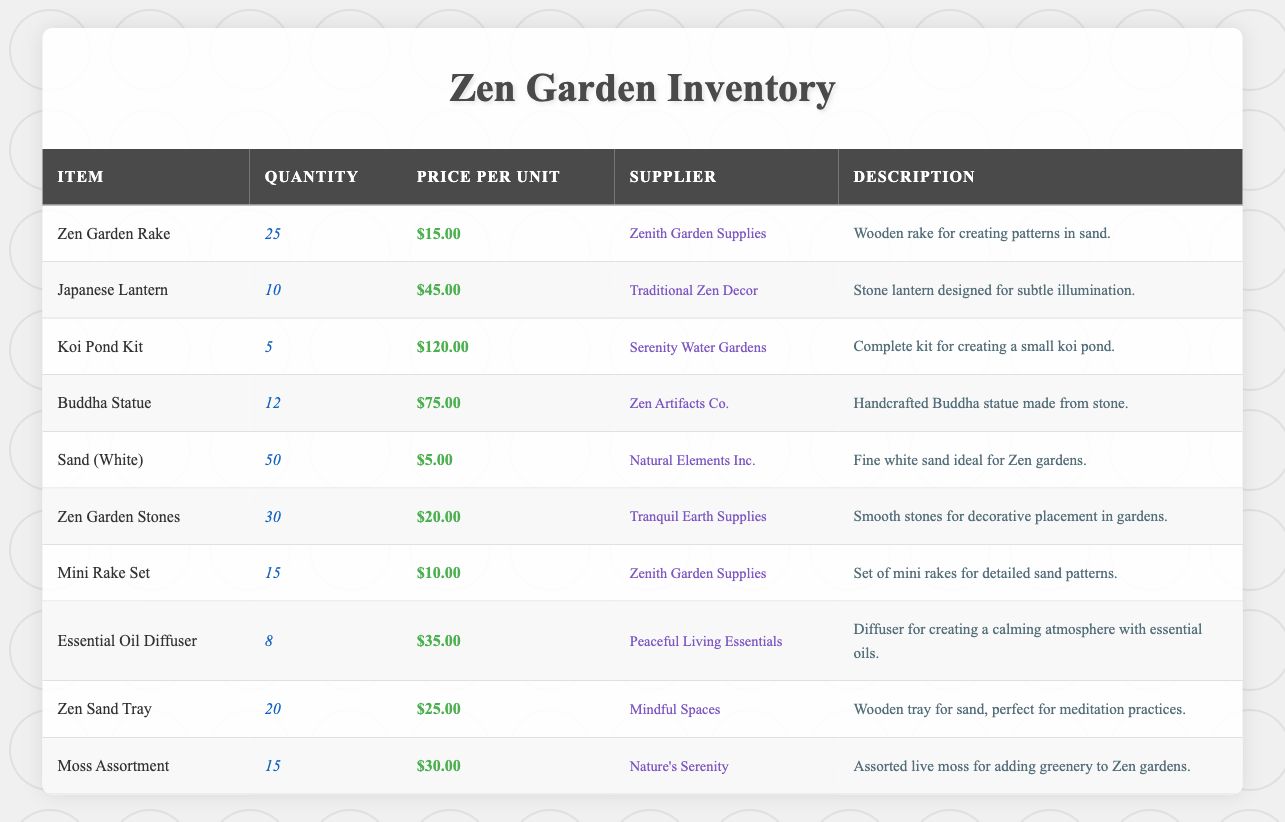What is the price of the Zen Garden Rake? The table lists the price per unit for each item. Looking at the row for the Zen Garden Rake, the price is displayed as $15.00.
Answer: $15.00 How many units of the Japanese Lantern are available? By checking the quantity column for the Japanese Lantern in the table, it shows that there are 10 units available.
Answer: 10 What is the total quantity of Sand (White) and Zen Garden Stones combined? To find the total quantity, we add the quantity of Sand (White) which is 50 and the quantity of Zen Garden Stones which is 30. Therefore, 50 + 30 = 80.
Answer: 80 Is the price of a Koi Pond Kit greater than the price of a Buddha Statue? We compare the price of the Koi Pond Kit, which is $120.00, to the price of the Buddha Statue, which is $75.00. Since $120.00 is greater than $75.00, the answer is yes.
Answer: Yes What is the average price of all the items listed in the inventory? To calculate the average price, we sum the individual prices: (15 + 45 + 120 + 75 + 5 + 20 + 10 + 35 + 25 + 30) =  455. We then divide by the total number of items, which is 10. Thus, 455 / 10 = 45.50.
Answer: 45.50 How many items have a quantity greater than 15? We examine each item's quantity: Zen Garden Rake (25), Sand (White) (50), Zen Garden Stones (30), and Zen Sand Tray (20) all have quantities greater than 15. Thus, there are 4 items with quantities greater than 15.
Answer: 4 Is the supplier for the Essential Oil Diffuser the same as for the Mini Rake Set? The supplier for the Essential Oil Diffuser is Peaceful Living Essentials, while the supplier for the Mini Rake Set is Zenith Garden Supplies. Since these suppliers are different, the answer is no.
Answer: No What item has the lowest stock available? We look at the quantity column and see that the Koi Pond Kit has the lowest quantity with only 5 units available.
Answer: Koi Pond Kit What is the total price of the available quantity of Buddha Statues? To find the total price, multiply the quantity (12) by the price per unit ($75.00). This results in 12 * 75 = $900.00.
Answer: $900.00 How many different suppliers are listed in the inventory? We count the unique suppliers from the supplier column: Zenith Garden Supplies, Traditional Zen Decor, Serenity Water Gardens, Zen Artifacts Co., Natural Elements Inc., Tranquil Earth Supplies, Peaceful Living Essentials, Mindful Spaces, and Nature's Serenity. There are 9 different suppliers.
Answer: 9 